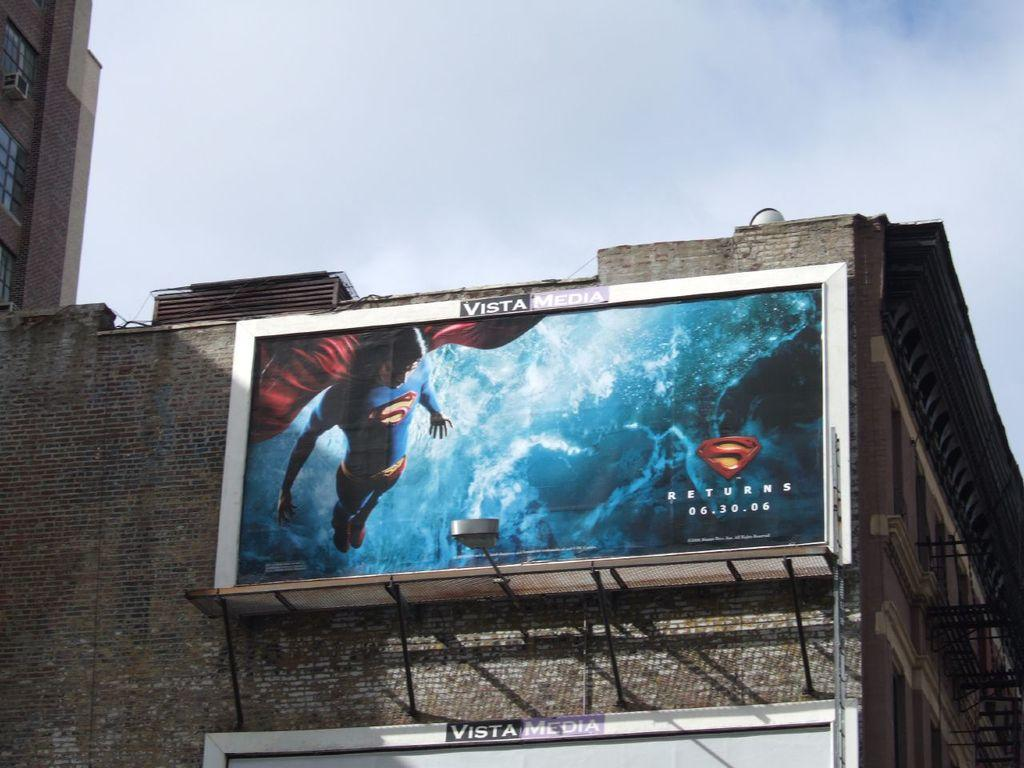<image>
Create a compact narrative representing the image presented. A billboard for the movie Superman Returns 06.30.06. 